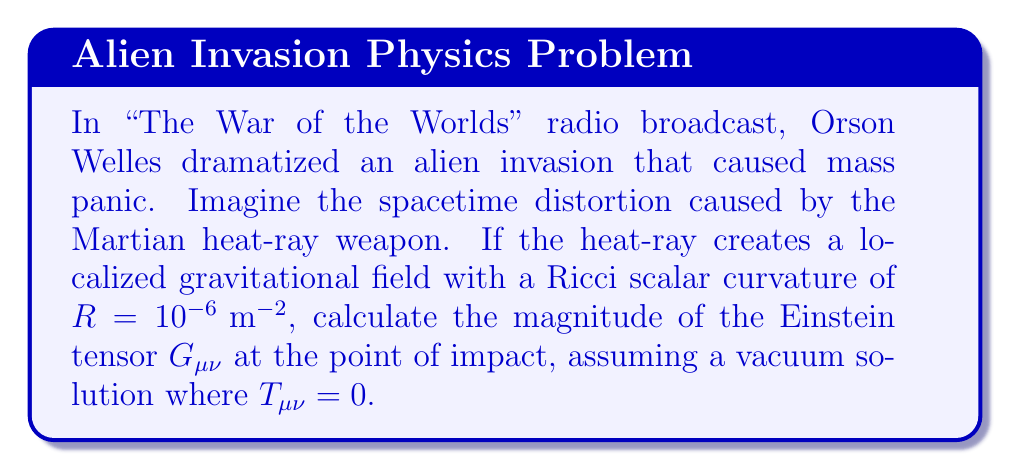Can you solve this math problem? Let's approach this step-by-step:

1) In general relativity, the Einstein field equations are given by:

   $$G_{\mu\nu} + \Lambda g_{\mu\nu} = \frac{8\pi G}{c^4} T_{\mu\nu}$$

   Where $G_{\mu\nu}$ is the Einstein tensor, $\Lambda$ is the cosmological constant, $g_{\mu\nu}$ is the metric tensor, $G$ is Newton's gravitational constant, $c$ is the speed of light, and $T_{\mu\nu}$ is the stress-energy tensor.

2) We're told that $T_{\mu\nu} = 0$ (vacuum solution), so our equation simplifies to:

   $$G_{\mu\nu} + \Lambda g_{\mu\nu} = 0$$

3) The Einstein tensor is related to the Ricci tensor $R_{\mu\nu}$ and the Ricci scalar $R$ by:

   $$G_{\mu\nu} = R_{\mu\nu} - \frac{1}{2}R g_{\mu\nu}$$

4) Taking the trace of both sides:

   $$G^\mu_\mu = R^\mu_\mu - \frac{1}{2}R g^\mu_\mu = R - \frac{1}{2}R \cdot 4 = -R$$

5) We're given that $R = 10^{-6} \text{ m}^{-2}$, so:

   $$G^\mu_\mu = -10^{-6} \text{ m}^{-2}$$

6) The magnitude of the Einstein tensor is the square root of the sum of its components squared:

   $$|G_{\mu\nu}| = \sqrt{\sum_{\mu,\nu} (G_{\mu\nu})^2} = \sqrt{(G^\mu_\mu)^2} = |-10^{-6}| = 10^{-6} \text{ m}^{-2}$$

Thus, the magnitude of the Einstein tensor at the point of impact is $10^{-6} \text{ m}^{-2}$.
Answer: $10^{-6} \text{ m}^{-2}$ 